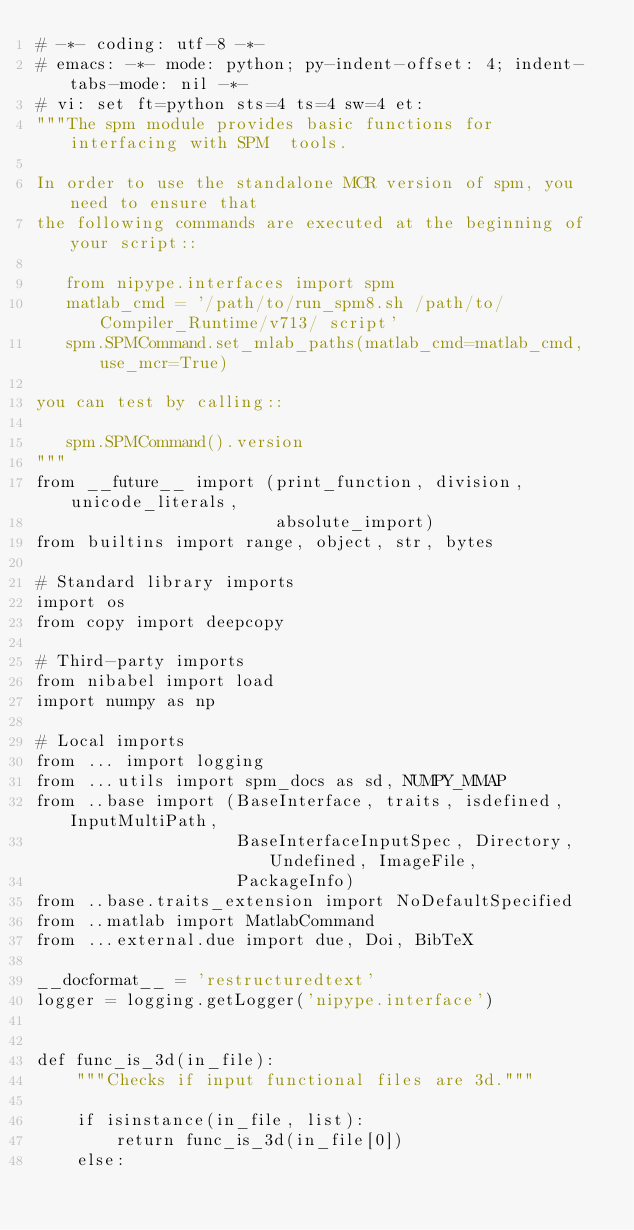<code> <loc_0><loc_0><loc_500><loc_500><_Python_># -*- coding: utf-8 -*-
# emacs: -*- mode: python; py-indent-offset: 4; indent-tabs-mode: nil -*-
# vi: set ft=python sts=4 ts=4 sw=4 et:
"""The spm module provides basic functions for interfacing with SPM  tools.

In order to use the standalone MCR version of spm, you need to ensure that
the following commands are executed at the beginning of your script::

   from nipype.interfaces import spm
   matlab_cmd = '/path/to/run_spm8.sh /path/to/Compiler_Runtime/v713/ script'
   spm.SPMCommand.set_mlab_paths(matlab_cmd=matlab_cmd, use_mcr=True)

you can test by calling::

   spm.SPMCommand().version
"""
from __future__ import (print_function, division, unicode_literals,
                        absolute_import)
from builtins import range, object, str, bytes

# Standard library imports
import os
from copy import deepcopy

# Third-party imports
from nibabel import load
import numpy as np

# Local imports
from ... import logging
from ...utils import spm_docs as sd, NUMPY_MMAP
from ..base import (BaseInterface, traits, isdefined, InputMultiPath,
                    BaseInterfaceInputSpec, Directory, Undefined, ImageFile,
                    PackageInfo)
from ..base.traits_extension import NoDefaultSpecified
from ..matlab import MatlabCommand
from ...external.due import due, Doi, BibTeX

__docformat__ = 'restructuredtext'
logger = logging.getLogger('nipype.interface')


def func_is_3d(in_file):
    """Checks if input functional files are 3d."""

    if isinstance(in_file, list):
        return func_is_3d(in_file[0])
    else:</code> 